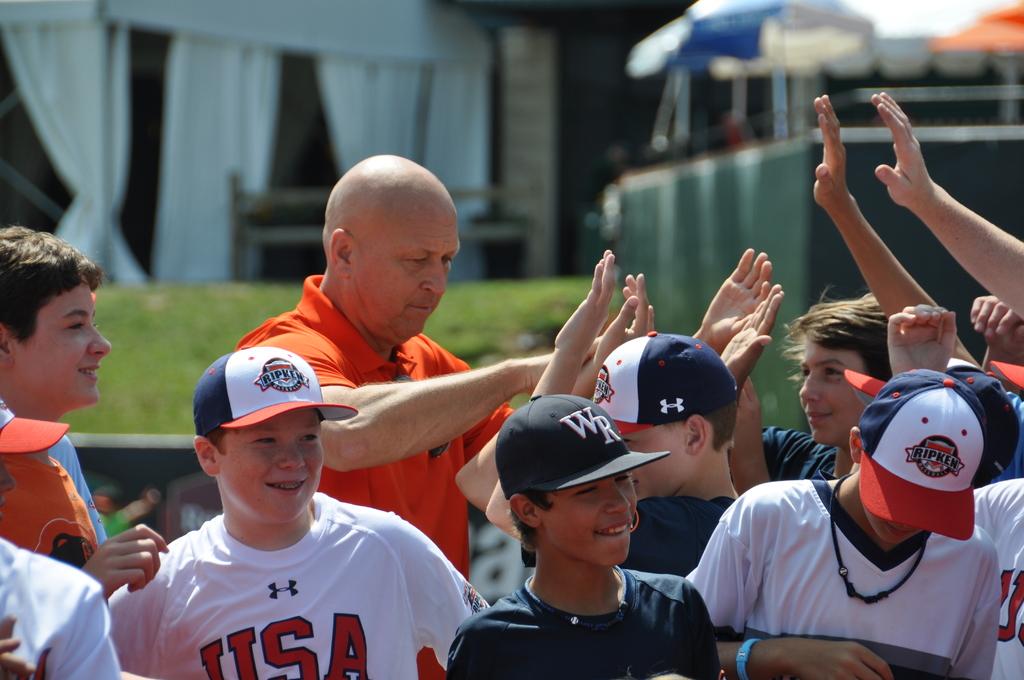What country jersey is the boy in white wearing?
Offer a terse response. Usa. What is the name on the white hats?
Offer a terse response. Ripken. 